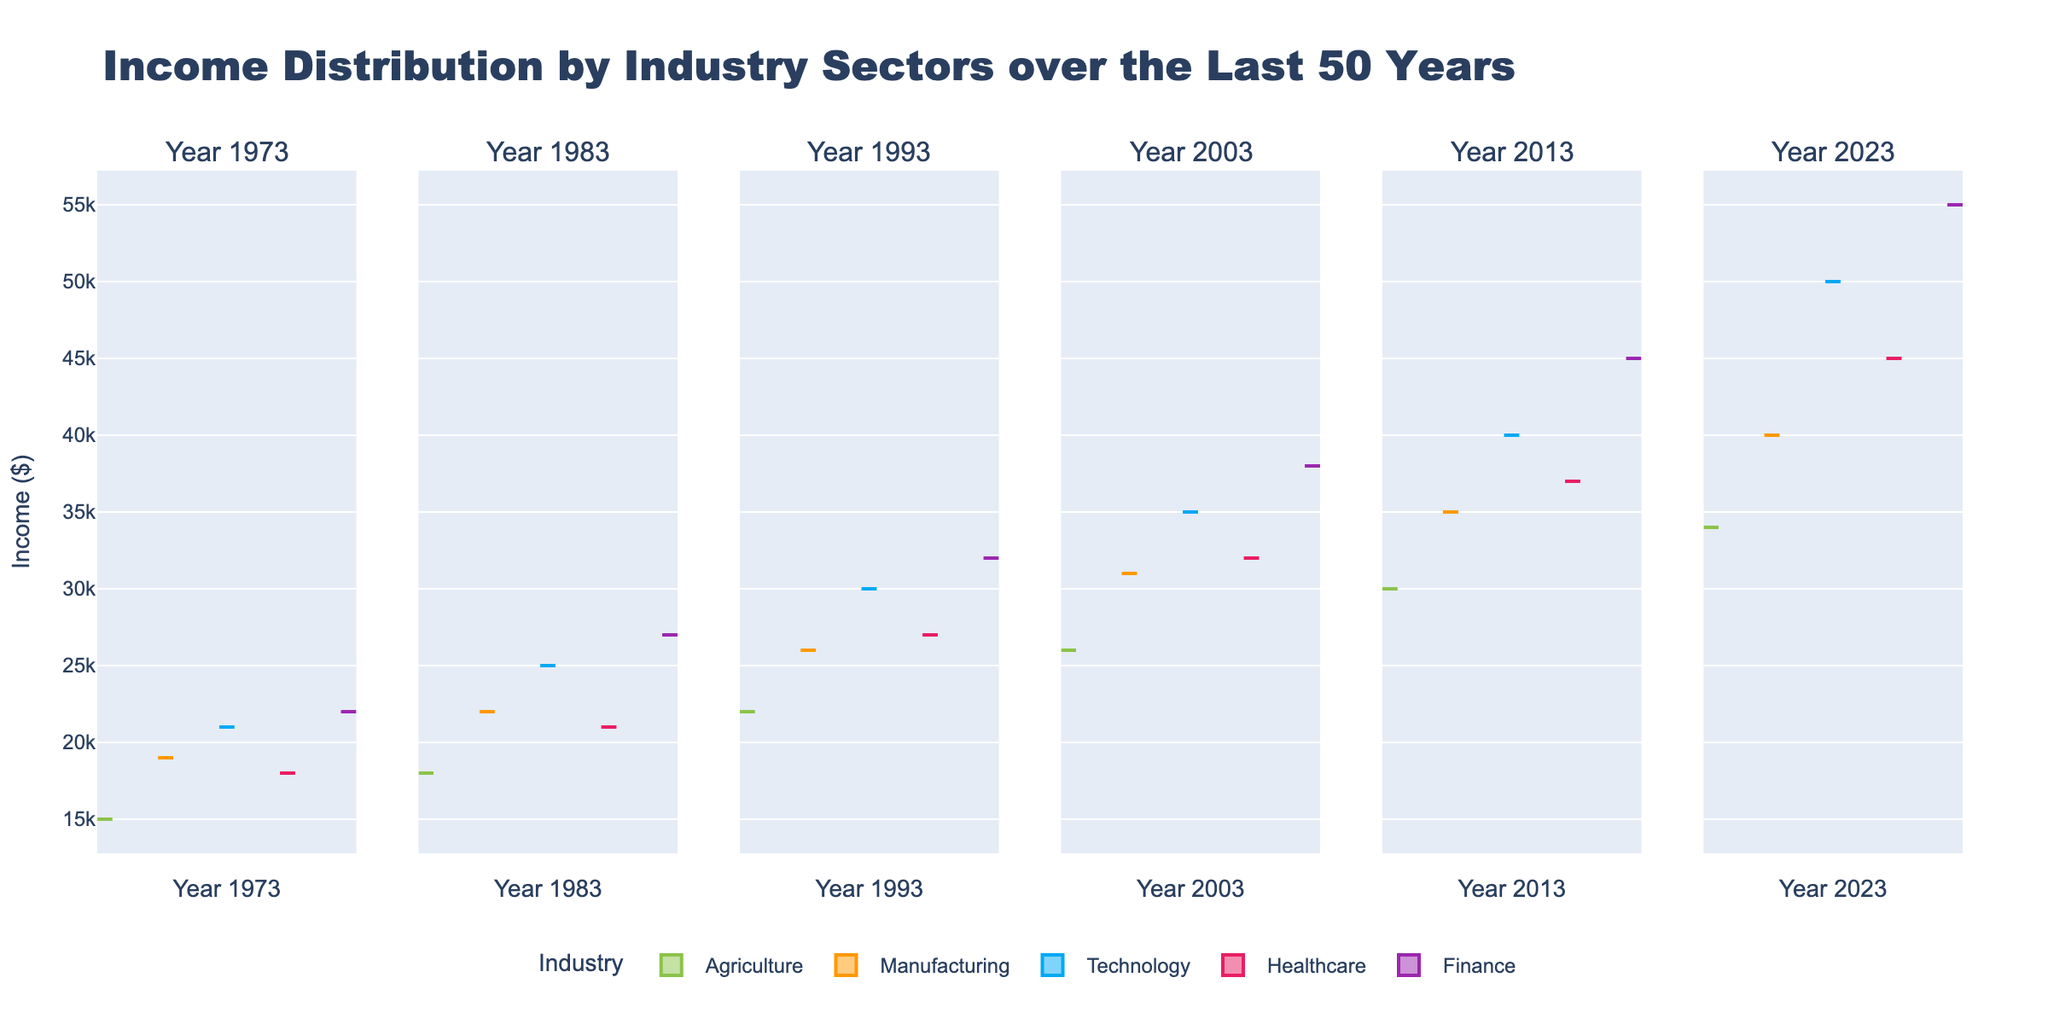What is the title of the figure? The title is typically placed at the top of the figure. Here, the title reads, "Income Distribution by Industry Sectors over the Last 50 Years".
Answer: Income Distribution by Industry Sectors over the Last 50 Years What is the income range for the Agriculture sector in 2023? Examine the Violin plot for the Agriculture sector in the 2023 column. The range is the vertical span of the violin. Visually, it shows incomes starting from around 34,000 dollars to around 36,000 dollars.
Answer: 34,000 to 36,000 dollars In which year does the Finance sector show the highest income distribution? Comparing the maximum values of the Finance sector in each column, the highest peak is in the 2023 column.
Answer: 2023 What color represents the Technology sector across all years? Identify the corresponding color for Technology sector in each subplot. It is marked in blue.
Answer: Blue Which industry sector has the widest distribution in 2013? Analyze the spread of each violin plot in the 2013 column. The one with the widest spread is the Finance sector.
Answer: Finance Between 1983 and 1993, how much did the median income of the Manufacturing sector increase? Check the median line within the Manufacturing sector violin plots for 1983 and 1993. The median changes from around 22,000 dollars in 1983 to around 26,000 dollars in 1993. So, the increase is 26,000 - 22,000 = 4,000 dollars.
Answer: 4,000 dollars Which sector shows the lowest income range in 1973? Compare the ranges of all violin plots in the 1973 column. The Agriculture sector has the lowest income range.
Answer: Agriculture In which year does the Healthcare sector first surpass the 30,000 dollar median income mark, and what was its value? Evaluate the median lines of the Healthcare sector from 1973 to 2023. The first year showing a median over 30,000 dollars is 2003, at around 32,000 dollars.
Answer: 2003, 32,000 dollars 